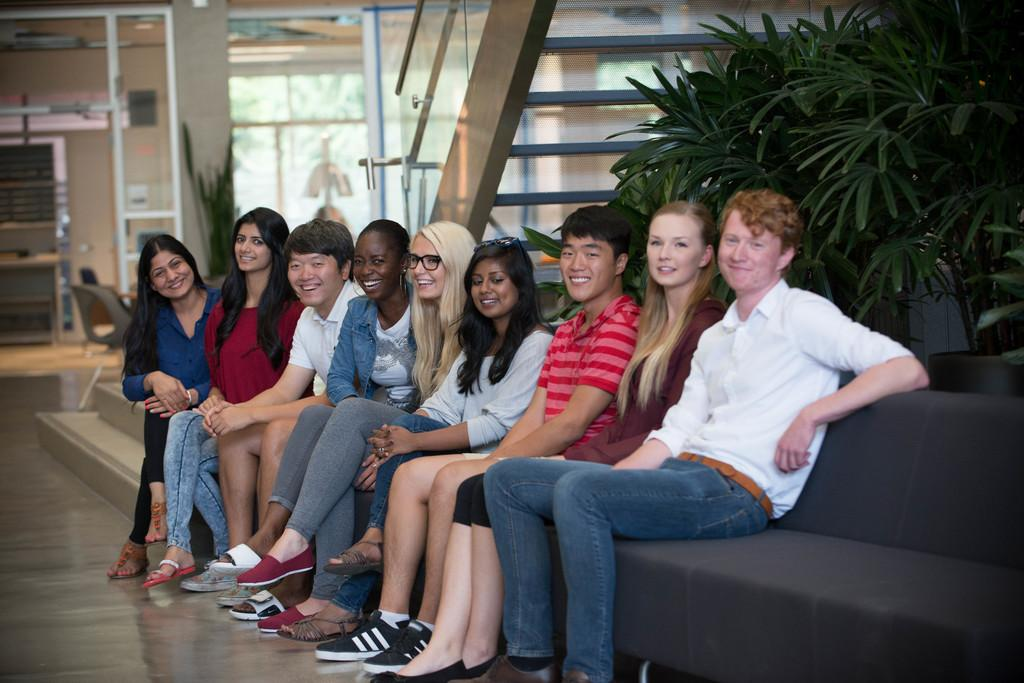What are the people in the image doing? The people in the image are sitting on the couch. What can be seen in the background of the image? There are trees, stairs, a chair, and a wall in the background. How can the trees be seen in the image? The trees are visible through a glass in the image. What type of grip does the plough have in the image? There is no plough present in the image. 